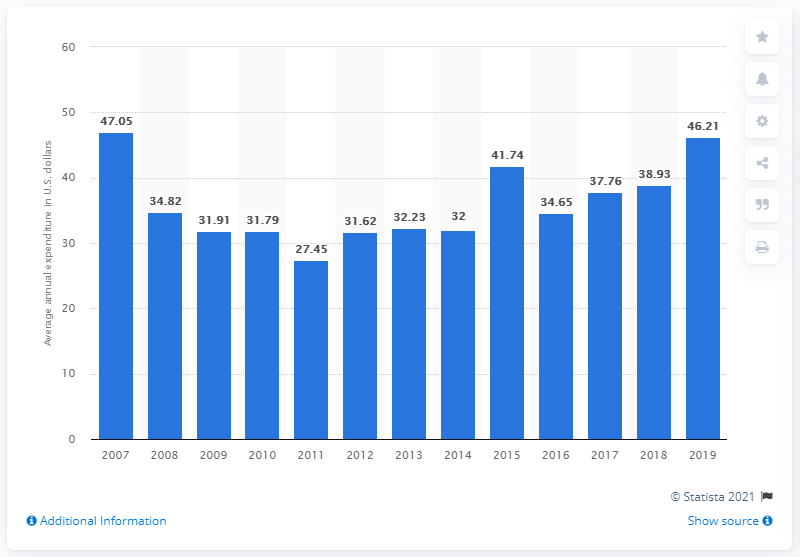Indicate a few pertinent items in this graphic. In the United States in 2019, the average expenditure on kitchen and dining room furniture per consumer unit was $46.21. 